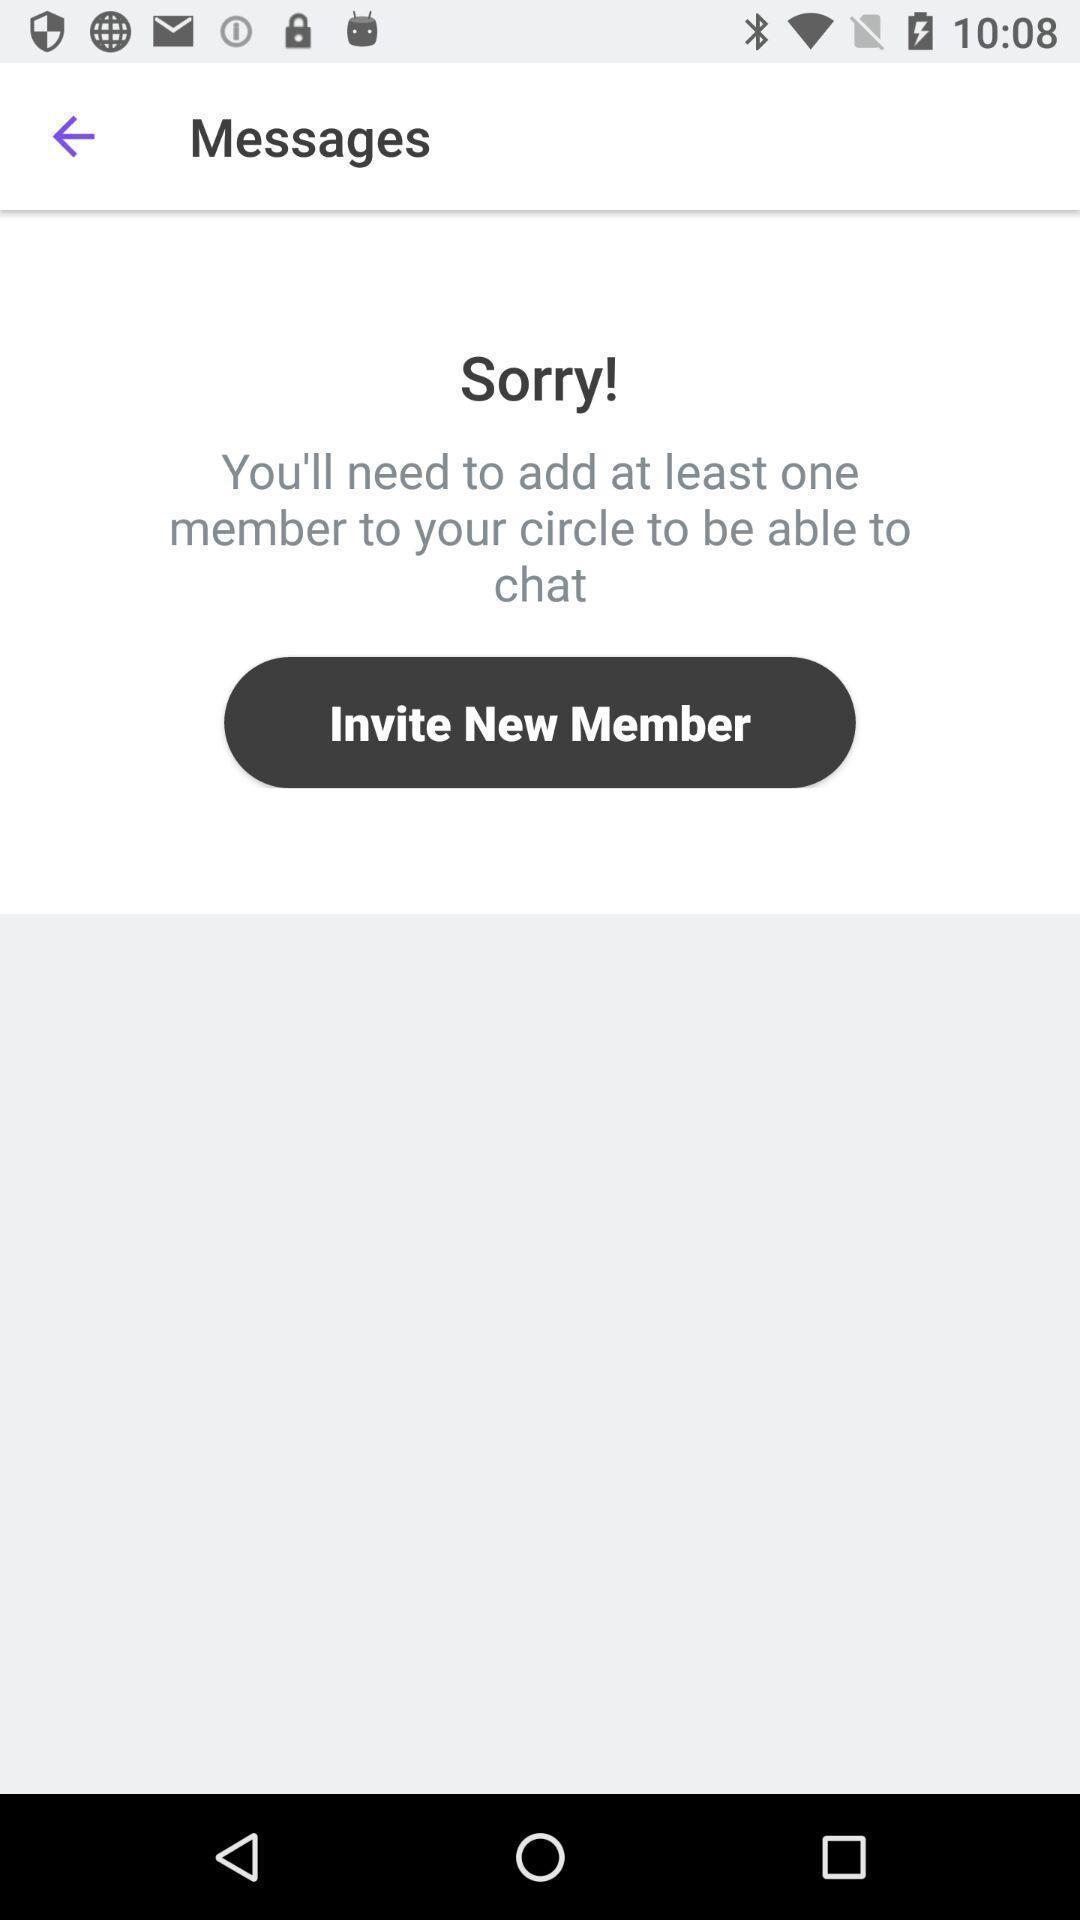Summarize the information in this screenshot. Screen shows message page with invite option in tracking app. 